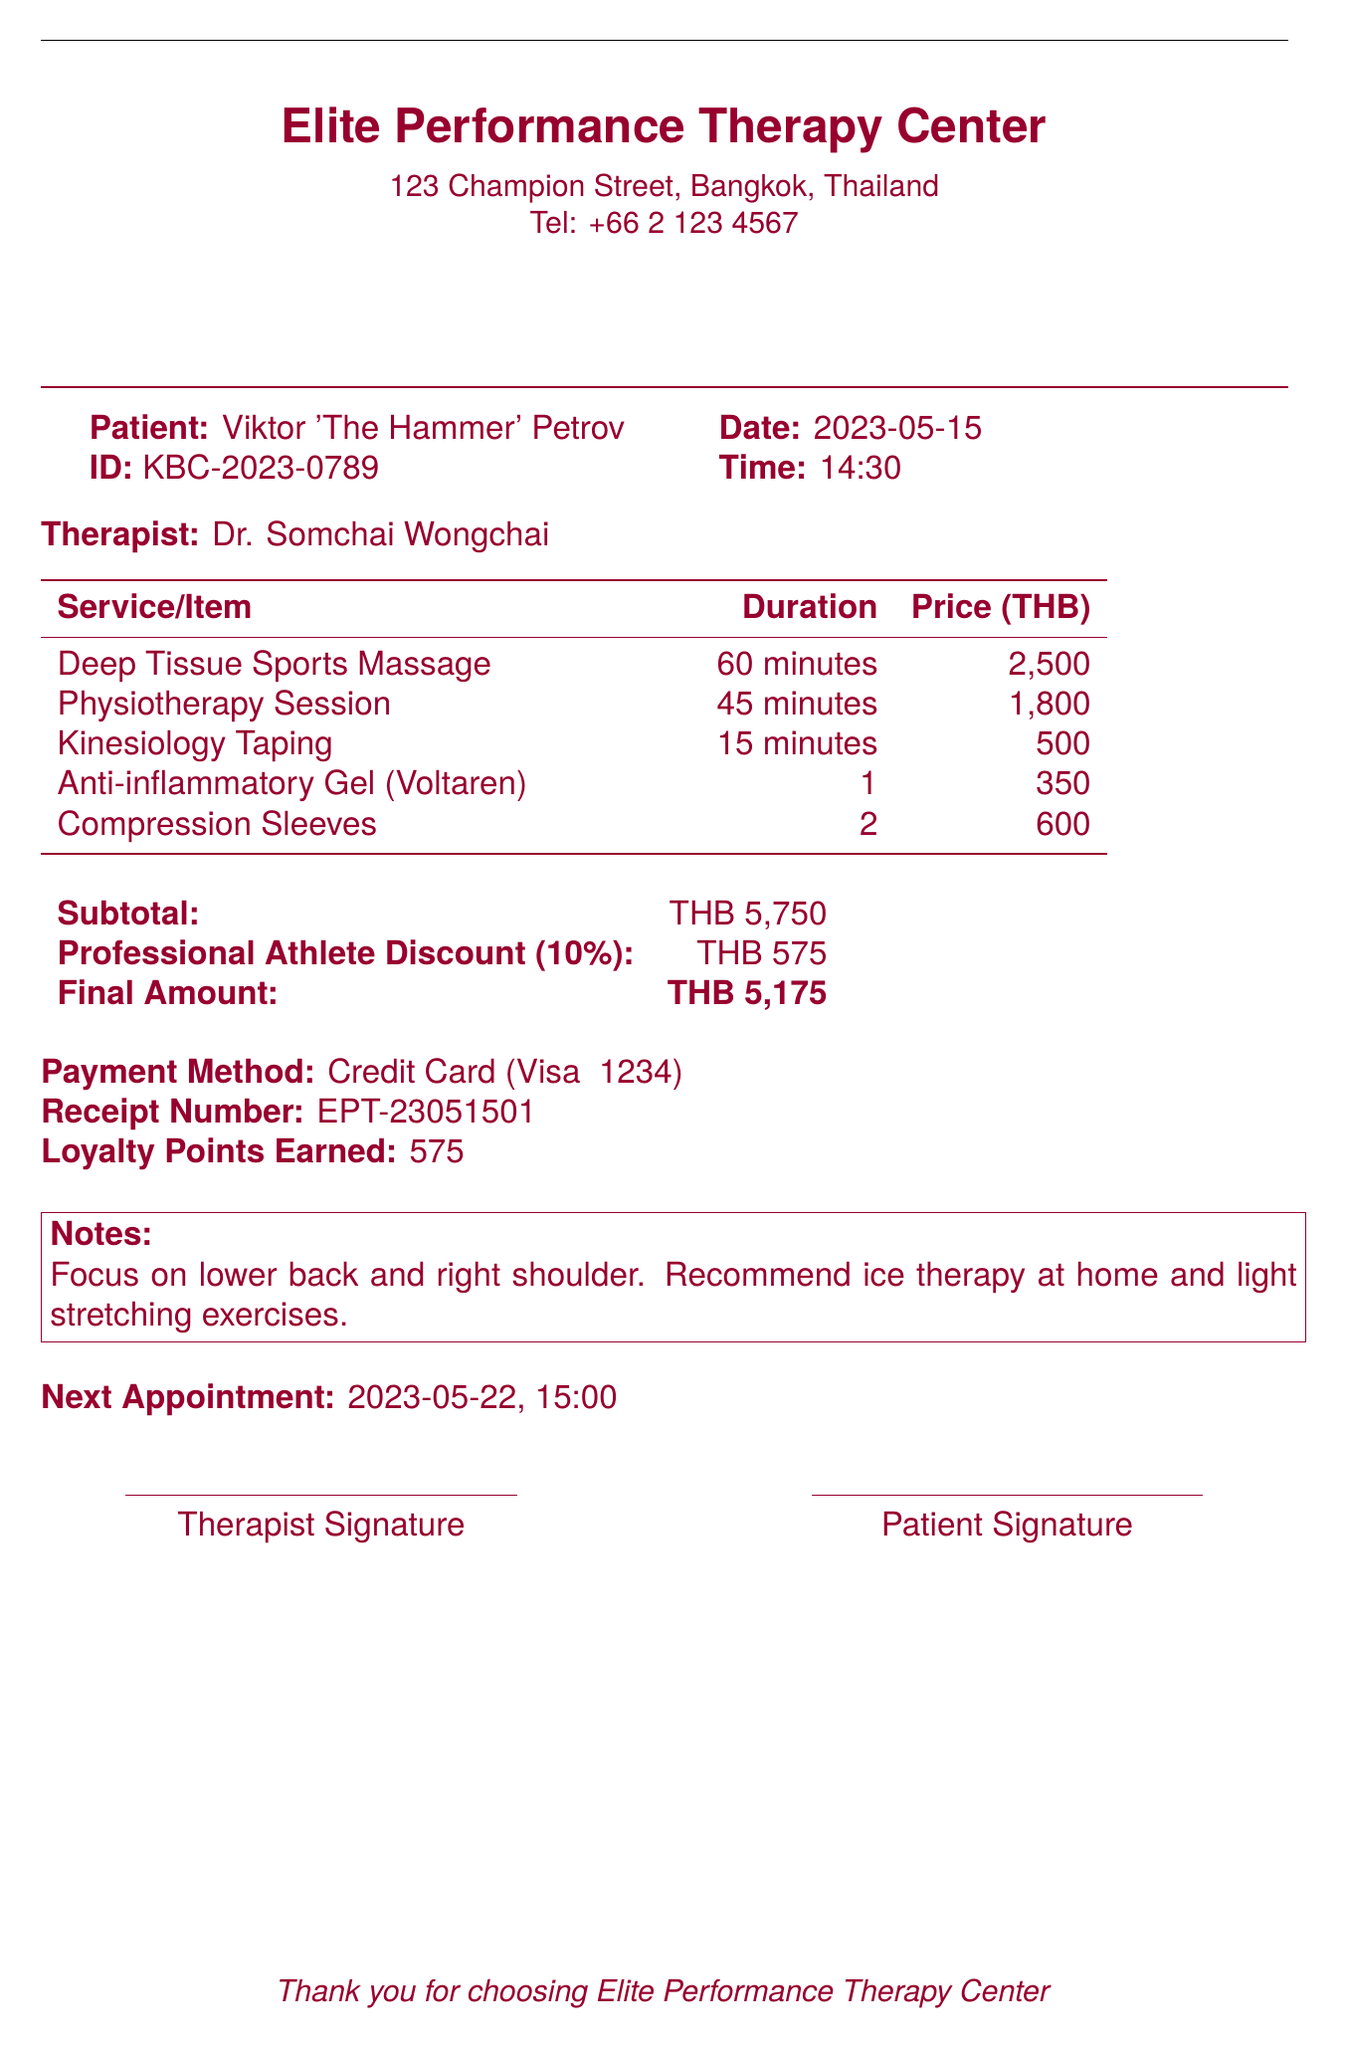what is the clinic's name? The clinic's name is located at the top of the document and is part of the clinic's header.
Answer: Elite Performance Therapy Center who was the therapist? The therapist's name is listed in the service section of the receipt.
Answer: Dr. Somchai Wongchai what date was the appointment? The date of the appointment can be found in the patient details section.
Answer: 2023-05-15 what is the total amount before the discount? The total amount before the discount is found under the subtotal section of the receipt.
Answer: 5750 how much was the Professional Athlete Discount? The discount amount is specified in the financial summary portion of the document.
Answer: 575 what is the duration of the Deep Tissue Sports Massage? The duration of the service is listed in the services table of the receipt.
Answer: 60 minutes what payment method was used? The payment method is specified in the payment details area of the receipt.
Answer: Credit Card when is the next appointment scheduled? The next appointment date and time are listed at the end of the document.
Answer: 2023-05-22, 15:00 how many loyalty points were earned? The loyalty points earned are shown in the financial summary section of the receipt.
Answer: 575 